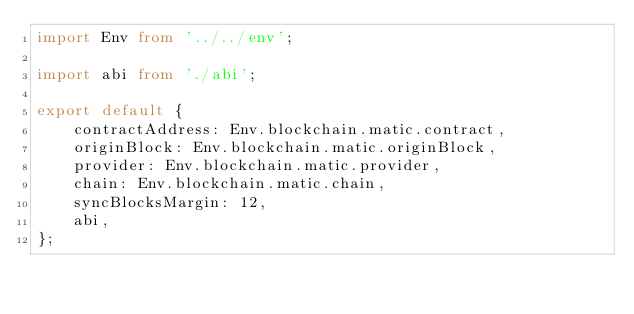<code> <loc_0><loc_0><loc_500><loc_500><_TypeScript_>import Env from '../../env';

import abi from './abi';

export default {
    contractAddress: Env.blockchain.matic.contract,
    originBlock: Env.blockchain.matic.originBlock,
    provider: Env.blockchain.matic.provider,
    chain: Env.blockchain.matic.chain,
    syncBlocksMargin: 12,
    abi,
};
</code> 